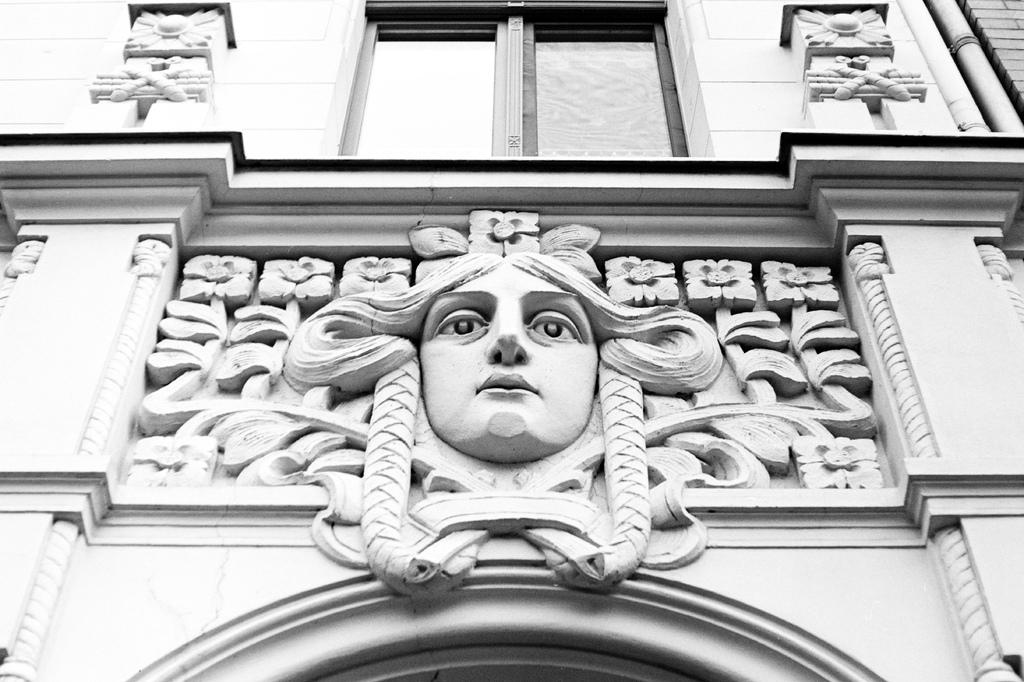What is the color scheme of the image? The image is black and white. What is the main subject of the image? There is a building in the image. What decorative element can be seen on the building? There is a sculpture on the wall of the building. What architectural features are visible on the building? Windows and pillars are present on the building. What type of yam is being used as a decoration on the building? There is no yam present in the image, as it is a black and white image of a building with a sculpture, windows, and pillars. 